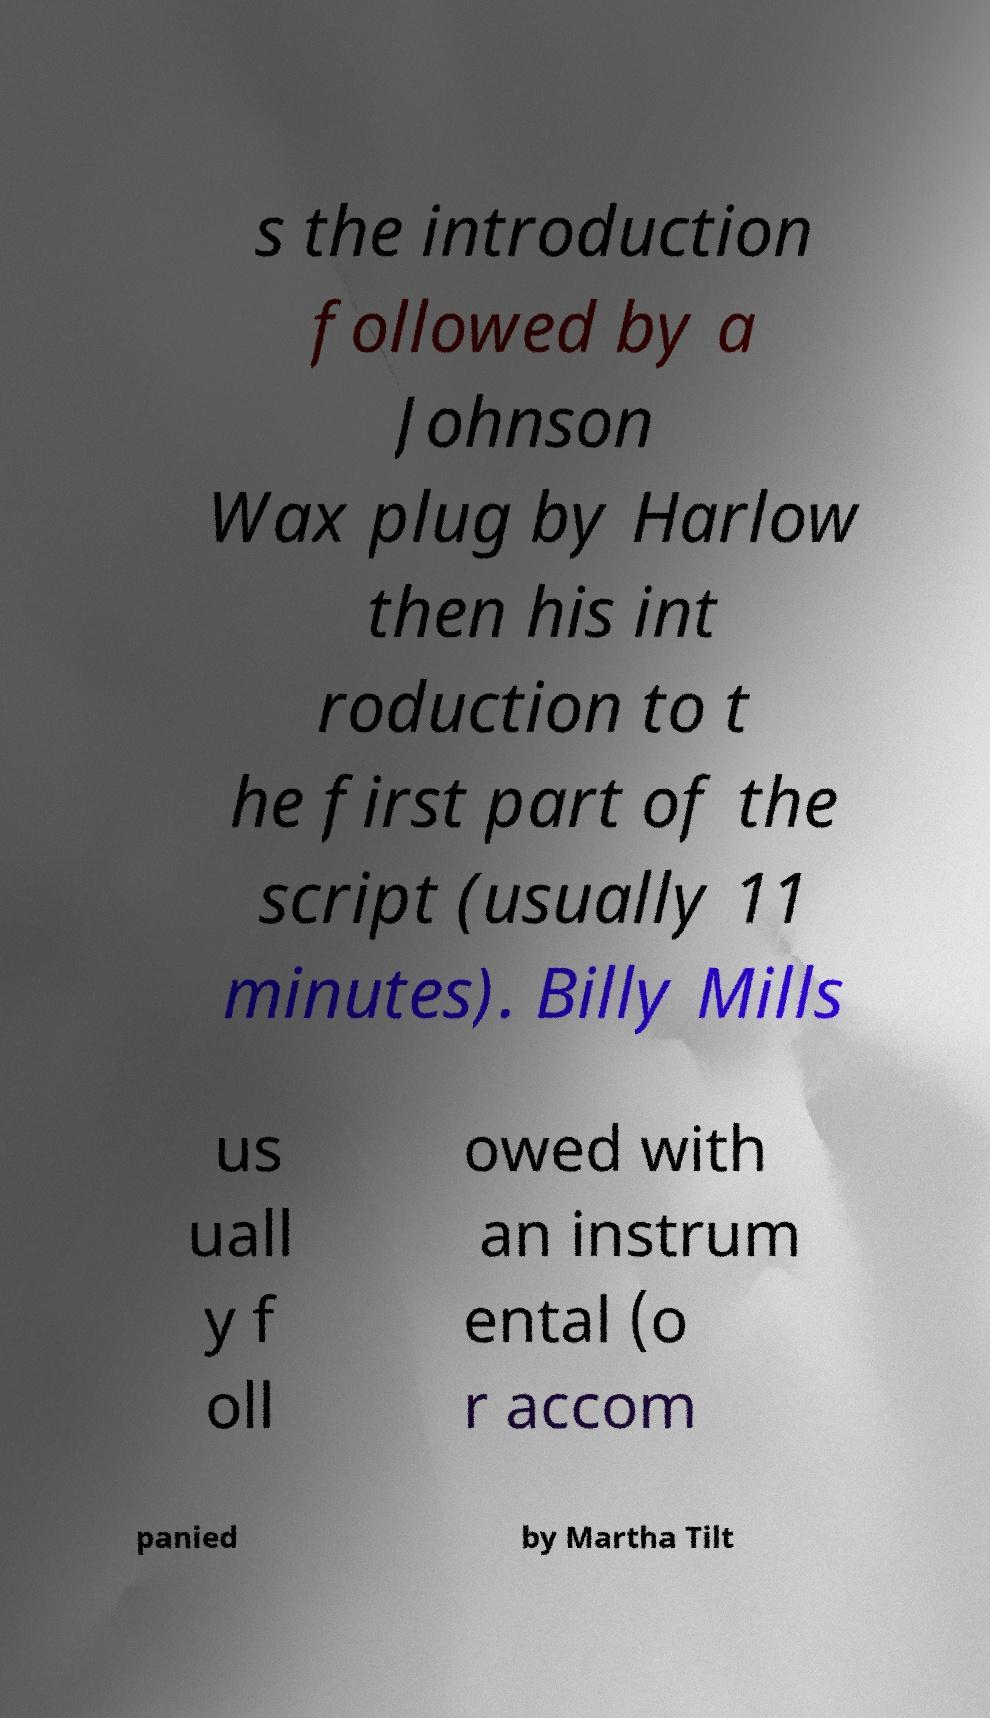Please identify and transcribe the text found in this image. s the introduction followed by a Johnson Wax plug by Harlow then his int roduction to t he first part of the script (usually 11 minutes). Billy Mills us uall y f oll owed with an instrum ental (o r accom panied by Martha Tilt 